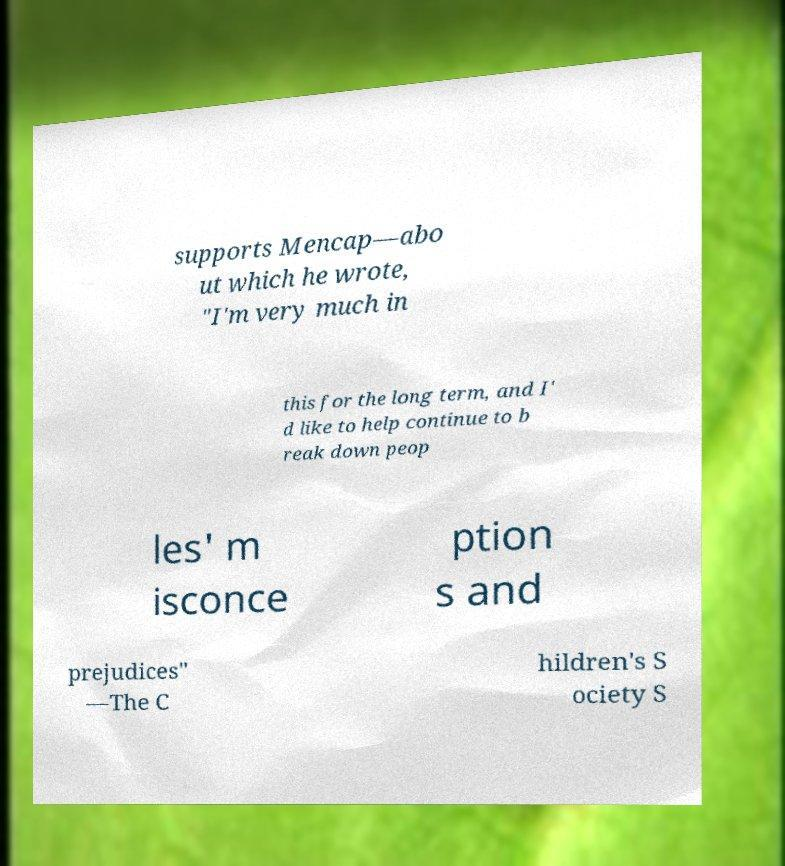I need the written content from this picture converted into text. Can you do that? supports Mencap—abo ut which he wrote, "I'm very much in this for the long term, and I' d like to help continue to b reak down peop les' m isconce ption s and prejudices" —The C hildren's S ociety S 